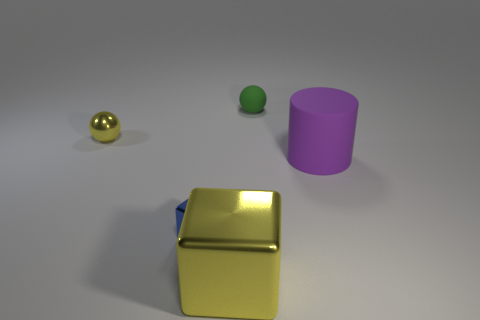There is a cube that is the same color as the small metallic ball; what is it made of?
Make the answer very short. Metal. There is a metal ball that is the same color as the large cube; what is its size?
Offer a very short reply. Small. Are there fewer yellow metal cubes than tiny objects?
Offer a terse response. Yes. There is a matte object that is behind the purple rubber thing; does it have the same color as the cylinder?
Ensure brevity in your answer.  No. What is the material of the large object that is behind the big thing left of the matte object that is on the right side of the green matte ball?
Your answer should be very brief. Rubber. Is there a cylinder of the same color as the tiny rubber ball?
Your answer should be compact. No. Are there fewer purple matte cylinders that are behind the large purple rubber thing than big cylinders?
Your answer should be compact. Yes. Is the size of the sphere on the right side of the blue shiny block the same as the small blue cube?
Your answer should be very brief. Yes. How many objects are behind the large shiny thing and to the right of the blue shiny thing?
Provide a short and direct response. 2. What size is the purple thing to the right of the sphere that is behind the shiny ball?
Give a very brief answer. Large. 